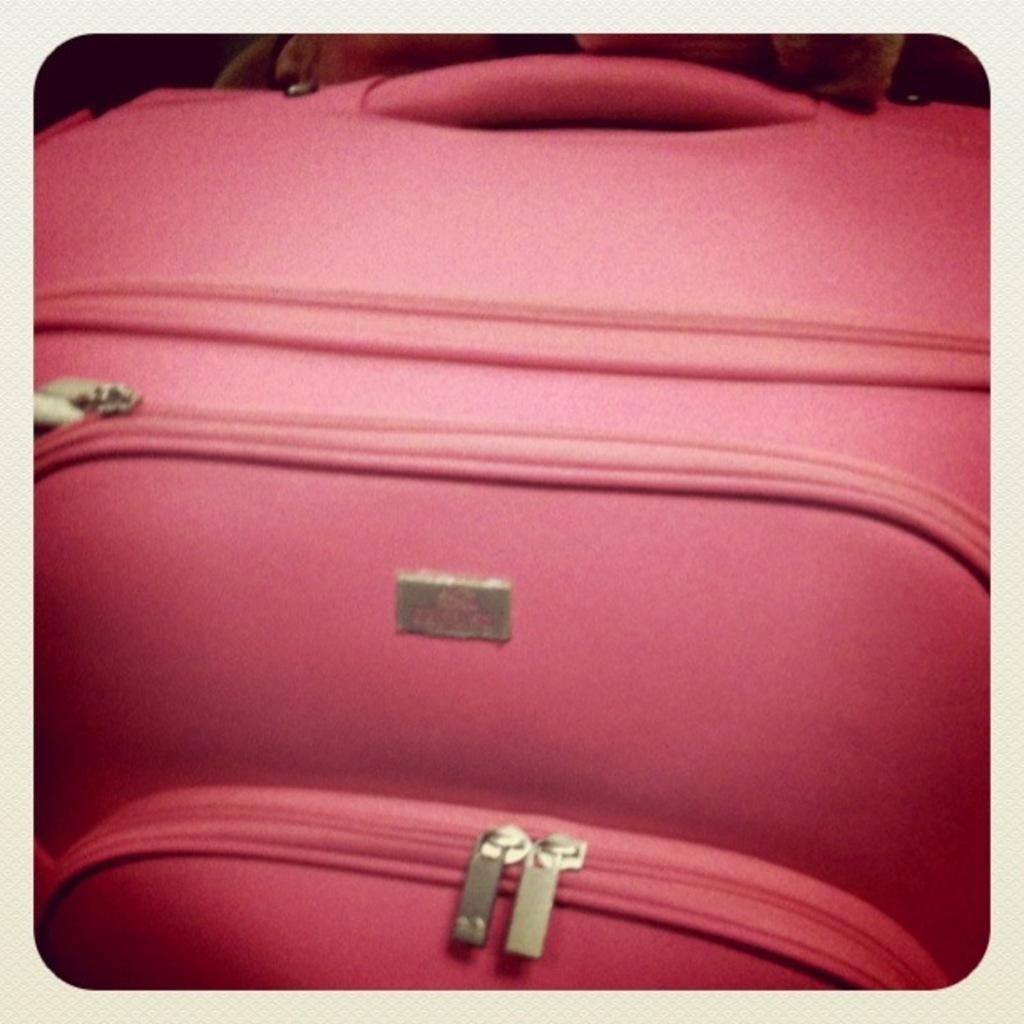How would you summarize this image in a sentence or two? In this image there is one suitcase that is pink in color. 